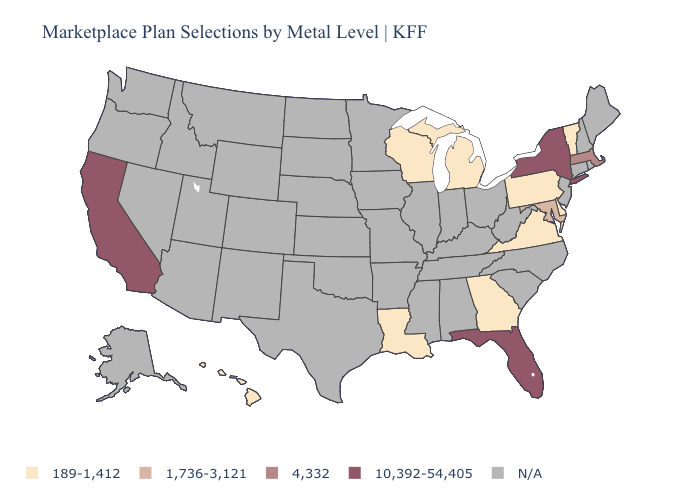Is the legend a continuous bar?
Short answer required. No. What is the value of Kentucky?
Answer briefly. N/A. What is the highest value in the MidWest ?
Short answer required. 189-1,412. What is the value of Texas?
Keep it brief. N/A. What is the highest value in the USA?
Concise answer only. 10,392-54,405. Name the states that have a value in the range 4,332?
Write a very short answer. Massachusetts. What is the value of Kentucky?
Concise answer only. N/A. Is the legend a continuous bar?
Answer briefly. No. What is the value of Colorado?
Keep it brief. N/A. Does the map have missing data?
Be succinct. Yes. What is the highest value in the USA?
Answer briefly. 10,392-54,405. Name the states that have a value in the range 1,736-3,121?
Be succinct. Maryland. Name the states that have a value in the range 189-1,412?
Write a very short answer. Delaware, Georgia, Hawaii, Louisiana, Michigan, Pennsylvania, Vermont, Virginia, Wisconsin. 